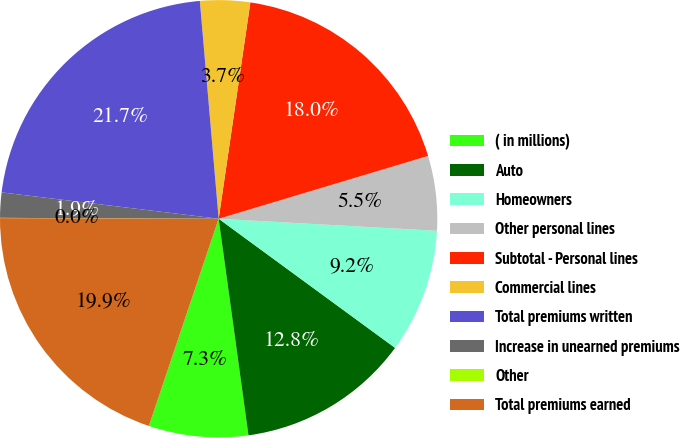Convert chart to OTSL. <chart><loc_0><loc_0><loc_500><loc_500><pie_chart><fcel>( in millions)<fcel>Auto<fcel>Homeowners<fcel>Other personal lines<fcel>Subtotal - Personal lines<fcel>Commercial lines<fcel>Total premiums written<fcel>Increase in unearned premiums<fcel>Other<fcel>Total premiums earned<nl><fcel>7.35%<fcel>12.77%<fcel>9.18%<fcel>5.52%<fcel>18.05%<fcel>3.69%<fcel>21.71%<fcel>1.86%<fcel>0.02%<fcel>19.88%<nl></chart> 